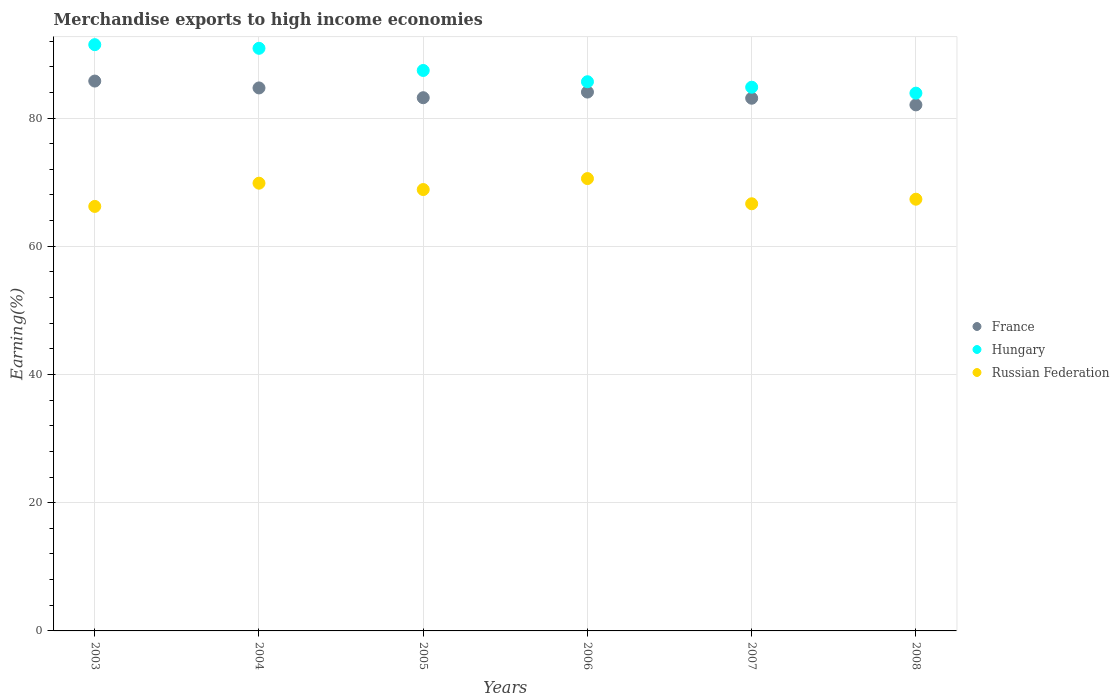How many different coloured dotlines are there?
Offer a terse response. 3. What is the percentage of amount earned from merchandise exports in Hungary in 2003?
Your answer should be very brief. 91.45. Across all years, what is the maximum percentage of amount earned from merchandise exports in Russian Federation?
Your response must be concise. 70.56. Across all years, what is the minimum percentage of amount earned from merchandise exports in Hungary?
Your answer should be very brief. 83.89. In which year was the percentage of amount earned from merchandise exports in Russian Federation maximum?
Your answer should be very brief. 2006. In which year was the percentage of amount earned from merchandise exports in France minimum?
Ensure brevity in your answer.  2008. What is the total percentage of amount earned from merchandise exports in France in the graph?
Offer a terse response. 502.85. What is the difference between the percentage of amount earned from merchandise exports in France in 2004 and that in 2008?
Your answer should be very brief. 2.64. What is the difference between the percentage of amount earned from merchandise exports in Hungary in 2006 and the percentage of amount earned from merchandise exports in France in 2008?
Give a very brief answer. 3.61. What is the average percentage of amount earned from merchandise exports in Russian Federation per year?
Give a very brief answer. 68.24. In the year 2006, what is the difference between the percentage of amount earned from merchandise exports in Russian Federation and percentage of amount earned from merchandise exports in France?
Your response must be concise. -13.49. What is the ratio of the percentage of amount earned from merchandise exports in France in 2003 to that in 2005?
Your answer should be compact. 1.03. What is the difference between the highest and the second highest percentage of amount earned from merchandise exports in France?
Make the answer very short. 1.07. What is the difference between the highest and the lowest percentage of amount earned from merchandise exports in France?
Provide a short and direct response. 3.71. Is the sum of the percentage of amount earned from merchandise exports in Hungary in 2003 and 2005 greater than the maximum percentage of amount earned from merchandise exports in Russian Federation across all years?
Your answer should be very brief. Yes. Does the percentage of amount earned from merchandise exports in Russian Federation monotonically increase over the years?
Provide a short and direct response. No. How many dotlines are there?
Give a very brief answer. 3. What is the difference between two consecutive major ticks on the Y-axis?
Keep it short and to the point. 20. How many legend labels are there?
Ensure brevity in your answer.  3. What is the title of the graph?
Provide a short and direct response. Merchandise exports to high income economies. Does "Eritrea" appear as one of the legend labels in the graph?
Your answer should be compact. No. What is the label or title of the Y-axis?
Provide a succinct answer. Earning(%). What is the Earning(%) of France in 2003?
Offer a very short reply. 85.77. What is the Earning(%) in Hungary in 2003?
Offer a very short reply. 91.45. What is the Earning(%) in Russian Federation in 2003?
Provide a succinct answer. 66.22. What is the Earning(%) of France in 2004?
Ensure brevity in your answer.  84.7. What is the Earning(%) in Hungary in 2004?
Ensure brevity in your answer.  90.88. What is the Earning(%) of Russian Federation in 2004?
Provide a succinct answer. 69.84. What is the Earning(%) in France in 2005?
Make the answer very short. 83.17. What is the Earning(%) in Hungary in 2005?
Your answer should be compact. 87.42. What is the Earning(%) of Russian Federation in 2005?
Your answer should be very brief. 68.85. What is the Earning(%) in France in 2006?
Your answer should be very brief. 84.05. What is the Earning(%) of Hungary in 2006?
Ensure brevity in your answer.  85.67. What is the Earning(%) in Russian Federation in 2006?
Offer a very short reply. 70.56. What is the Earning(%) in France in 2007?
Keep it short and to the point. 83.09. What is the Earning(%) of Hungary in 2007?
Your response must be concise. 84.81. What is the Earning(%) in Russian Federation in 2007?
Your response must be concise. 66.63. What is the Earning(%) of France in 2008?
Your answer should be very brief. 82.06. What is the Earning(%) of Hungary in 2008?
Make the answer very short. 83.89. What is the Earning(%) in Russian Federation in 2008?
Your response must be concise. 67.34. Across all years, what is the maximum Earning(%) in France?
Keep it short and to the point. 85.77. Across all years, what is the maximum Earning(%) of Hungary?
Offer a terse response. 91.45. Across all years, what is the maximum Earning(%) in Russian Federation?
Make the answer very short. 70.56. Across all years, what is the minimum Earning(%) of France?
Make the answer very short. 82.06. Across all years, what is the minimum Earning(%) of Hungary?
Make the answer very short. 83.89. Across all years, what is the minimum Earning(%) in Russian Federation?
Provide a succinct answer. 66.22. What is the total Earning(%) of France in the graph?
Offer a very short reply. 502.85. What is the total Earning(%) in Hungary in the graph?
Your answer should be compact. 524.12. What is the total Earning(%) of Russian Federation in the graph?
Your response must be concise. 409.45. What is the difference between the Earning(%) of France in 2003 and that in 2004?
Ensure brevity in your answer.  1.07. What is the difference between the Earning(%) in Hungary in 2003 and that in 2004?
Provide a short and direct response. 0.57. What is the difference between the Earning(%) in Russian Federation in 2003 and that in 2004?
Provide a short and direct response. -3.62. What is the difference between the Earning(%) of France in 2003 and that in 2005?
Keep it short and to the point. 2.6. What is the difference between the Earning(%) of Hungary in 2003 and that in 2005?
Your response must be concise. 4.03. What is the difference between the Earning(%) in Russian Federation in 2003 and that in 2005?
Your response must be concise. -2.63. What is the difference between the Earning(%) of France in 2003 and that in 2006?
Offer a very short reply. 1.72. What is the difference between the Earning(%) in Hungary in 2003 and that in 2006?
Provide a succinct answer. 5.78. What is the difference between the Earning(%) in Russian Federation in 2003 and that in 2006?
Provide a short and direct response. -4.34. What is the difference between the Earning(%) in France in 2003 and that in 2007?
Offer a very short reply. 2.68. What is the difference between the Earning(%) of Hungary in 2003 and that in 2007?
Provide a short and direct response. 6.64. What is the difference between the Earning(%) of Russian Federation in 2003 and that in 2007?
Your answer should be very brief. -0.41. What is the difference between the Earning(%) in France in 2003 and that in 2008?
Offer a very short reply. 3.71. What is the difference between the Earning(%) in Hungary in 2003 and that in 2008?
Provide a succinct answer. 7.56. What is the difference between the Earning(%) of Russian Federation in 2003 and that in 2008?
Ensure brevity in your answer.  -1.13. What is the difference between the Earning(%) of France in 2004 and that in 2005?
Keep it short and to the point. 1.53. What is the difference between the Earning(%) of Hungary in 2004 and that in 2005?
Make the answer very short. 3.46. What is the difference between the Earning(%) in France in 2004 and that in 2006?
Make the answer very short. 0.65. What is the difference between the Earning(%) of Hungary in 2004 and that in 2006?
Give a very brief answer. 5.21. What is the difference between the Earning(%) of Russian Federation in 2004 and that in 2006?
Provide a succinct answer. -0.72. What is the difference between the Earning(%) in France in 2004 and that in 2007?
Make the answer very short. 1.61. What is the difference between the Earning(%) in Hungary in 2004 and that in 2007?
Offer a terse response. 6.07. What is the difference between the Earning(%) in Russian Federation in 2004 and that in 2007?
Ensure brevity in your answer.  3.21. What is the difference between the Earning(%) in France in 2004 and that in 2008?
Make the answer very short. 2.64. What is the difference between the Earning(%) in Hungary in 2004 and that in 2008?
Your answer should be very brief. 6.99. What is the difference between the Earning(%) of Russian Federation in 2004 and that in 2008?
Keep it short and to the point. 2.5. What is the difference between the Earning(%) of France in 2005 and that in 2006?
Ensure brevity in your answer.  -0.88. What is the difference between the Earning(%) of Hungary in 2005 and that in 2006?
Your answer should be compact. 1.76. What is the difference between the Earning(%) of Russian Federation in 2005 and that in 2006?
Provide a succinct answer. -1.71. What is the difference between the Earning(%) of France in 2005 and that in 2007?
Your answer should be compact. 0.08. What is the difference between the Earning(%) of Hungary in 2005 and that in 2007?
Ensure brevity in your answer.  2.61. What is the difference between the Earning(%) of Russian Federation in 2005 and that in 2007?
Your response must be concise. 2.22. What is the difference between the Earning(%) of France in 2005 and that in 2008?
Give a very brief answer. 1.12. What is the difference between the Earning(%) of Hungary in 2005 and that in 2008?
Your response must be concise. 3.54. What is the difference between the Earning(%) of Russian Federation in 2005 and that in 2008?
Keep it short and to the point. 1.51. What is the difference between the Earning(%) of France in 2006 and that in 2007?
Your answer should be very brief. 0.96. What is the difference between the Earning(%) in Hungary in 2006 and that in 2007?
Your answer should be compact. 0.85. What is the difference between the Earning(%) of Russian Federation in 2006 and that in 2007?
Your response must be concise. 3.93. What is the difference between the Earning(%) in France in 2006 and that in 2008?
Your response must be concise. 2. What is the difference between the Earning(%) of Hungary in 2006 and that in 2008?
Your response must be concise. 1.78. What is the difference between the Earning(%) of Russian Federation in 2006 and that in 2008?
Keep it short and to the point. 3.22. What is the difference between the Earning(%) in France in 2007 and that in 2008?
Offer a very short reply. 1.04. What is the difference between the Earning(%) in Hungary in 2007 and that in 2008?
Keep it short and to the point. 0.93. What is the difference between the Earning(%) of Russian Federation in 2007 and that in 2008?
Make the answer very short. -0.71. What is the difference between the Earning(%) of France in 2003 and the Earning(%) of Hungary in 2004?
Your response must be concise. -5.11. What is the difference between the Earning(%) in France in 2003 and the Earning(%) in Russian Federation in 2004?
Provide a short and direct response. 15.93. What is the difference between the Earning(%) in Hungary in 2003 and the Earning(%) in Russian Federation in 2004?
Ensure brevity in your answer.  21.61. What is the difference between the Earning(%) in France in 2003 and the Earning(%) in Hungary in 2005?
Your answer should be compact. -1.65. What is the difference between the Earning(%) of France in 2003 and the Earning(%) of Russian Federation in 2005?
Give a very brief answer. 16.92. What is the difference between the Earning(%) of Hungary in 2003 and the Earning(%) of Russian Federation in 2005?
Offer a terse response. 22.6. What is the difference between the Earning(%) of France in 2003 and the Earning(%) of Hungary in 2006?
Give a very brief answer. 0.11. What is the difference between the Earning(%) of France in 2003 and the Earning(%) of Russian Federation in 2006?
Your answer should be very brief. 15.21. What is the difference between the Earning(%) of Hungary in 2003 and the Earning(%) of Russian Federation in 2006?
Keep it short and to the point. 20.89. What is the difference between the Earning(%) of France in 2003 and the Earning(%) of Hungary in 2007?
Your answer should be compact. 0.96. What is the difference between the Earning(%) of France in 2003 and the Earning(%) of Russian Federation in 2007?
Offer a very short reply. 19.14. What is the difference between the Earning(%) in Hungary in 2003 and the Earning(%) in Russian Federation in 2007?
Your answer should be compact. 24.82. What is the difference between the Earning(%) of France in 2003 and the Earning(%) of Hungary in 2008?
Ensure brevity in your answer.  1.89. What is the difference between the Earning(%) in France in 2003 and the Earning(%) in Russian Federation in 2008?
Keep it short and to the point. 18.43. What is the difference between the Earning(%) of Hungary in 2003 and the Earning(%) of Russian Federation in 2008?
Your response must be concise. 24.11. What is the difference between the Earning(%) of France in 2004 and the Earning(%) of Hungary in 2005?
Your response must be concise. -2.73. What is the difference between the Earning(%) in France in 2004 and the Earning(%) in Russian Federation in 2005?
Give a very brief answer. 15.85. What is the difference between the Earning(%) in Hungary in 2004 and the Earning(%) in Russian Federation in 2005?
Offer a terse response. 22.03. What is the difference between the Earning(%) of France in 2004 and the Earning(%) of Hungary in 2006?
Ensure brevity in your answer.  -0.97. What is the difference between the Earning(%) of France in 2004 and the Earning(%) of Russian Federation in 2006?
Give a very brief answer. 14.14. What is the difference between the Earning(%) of Hungary in 2004 and the Earning(%) of Russian Federation in 2006?
Keep it short and to the point. 20.32. What is the difference between the Earning(%) of France in 2004 and the Earning(%) of Hungary in 2007?
Provide a succinct answer. -0.11. What is the difference between the Earning(%) of France in 2004 and the Earning(%) of Russian Federation in 2007?
Provide a short and direct response. 18.07. What is the difference between the Earning(%) of Hungary in 2004 and the Earning(%) of Russian Federation in 2007?
Your answer should be very brief. 24.25. What is the difference between the Earning(%) of France in 2004 and the Earning(%) of Hungary in 2008?
Your response must be concise. 0.81. What is the difference between the Earning(%) in France in 2004 and the Earning(%) in Russian Federation in 2008?
Make the answer very short. 17.36. What is the difference between the Earning(%) in Hungary in 2004 and the Earning(%) in Russian Federation in 2008?
Offer a terse response. 23.54. What is the difference between the Earning(%) of France in 2005 and the Earning(%) of Hungary in 2006?
Make the answer very short. -2.49. What is the difference between the Earning(%) in France in 2005 and the Earning(%) in Russian Federation in 2006?
Make the answer very short. 12.61. What is the difference between the Earning(%) in Hungary in 2005 and the Earning(%) in Russian Federation in 2006?
Offer a terse response. 16.86. What is the difference between the Earning(%) in France in 2005 and the Earning(%) in Hungary in 2007?
Offer a terse response. -1.64. What is the difference between the Earning(%) of France in 2005 and the Earning(%) of Russian Federation in 2007?
Provide a short and direct response. 16.54. What is the difference between the Earning(%) of Hungary in 2005 and the Earning(%) of Russian Federation in 2007?
Provide a short and direct response. 20.79. What is the difference between the Earning(%) of France in 2005 and the Earning(%) of Hungary in 2008?
Your answer should be compact. -0.71. What is the difference between the Earning(%) of France in 2005 and the Earning(%) of Russian Federation in 2008?
Give a very brief answer. 15.83. What is the difference between the Earning(%) of Hungary in 2005 and the Earning(%) of Russian Federation in 2008?
Provide a succinct answer. 20.08. What is the difference between the Earning(%) of France in 2006 and the Earning(%) of Hungary in 2007?
Your answer should be compact. -0.76. What is the difference between the Earning(%) in France in 2006 and the Earning(%) in Russian Federation in 2007?
Ensure brevity in your answer.  17.42. What is the difference between the Earning(%) in Hungary in 2006 and the Earning(%) in Russian Federation in 2007?
Give a very brief answer. 19.03. What is the difference between the Earning(%) of France in 2006 and the Earning(%) of Hungary in 2008?
Offer a very short reply. 0.17. What is the difference between the Earning(%) in France in 2006 and the Earning(%) in Russian Federation in 2008?
Your answer should be compact. 16.71. What is the difference between the Earning(%) of Hungary in 2006 and the Earning(%) of Russian Federation in 2008?
Make the answer very short. 18.32. What is the difference between the Earning(%) of France in 2007 and the Earning(%) of Hungary in 2008?
Ensure brevity in your answer.  -0.79. What is the difference between the Earning(%) in France in 2007 and the Earning(%) in Russian Federation in 2008?
Offer a terse response. 15.75. What is the difference between the Earning(%) of Hungary in 2007 and the Earning(%) of Russian Federation in 2008?
Offer a very short reply. 17.47. What is the average Earning(%) in France per year?
Offer a very short reply. 83.81. What is the average Earning(%) of Hungary per year?
Offer a very short reply. 87.35. What is the average Earning(%) of Russian Federation per year?
Offer a very short reply. 68.24. In the year 2003, what is the difference between the Earning(%) of France and Earning(%) of Hungary?
Provide a short and direct response. -5.68. In the year 2003, what is the difference between the Earning(%) of France and Earning(%) of Russian Federation?
Keep it short and to the point. 19.55. In the year 2003, what is the difference between the Earning(%) in Hungary and Earning(%) in Russian Federation?
Provide a succinct answer. 25.23. In the year 2004, what is the difference between the Earning(%) in France and Earning(%) in Hungary?
Offer a very short reply. -6.18. In the year 2004, what is the difference between the Earning(%) of France and Earning(%) of Russian Federation?
Your answer should be very brief. 14.86. In the year 2004, what is the difference between the Earning(%) of Hungary and Earning(%) of Russian Federation?
Offer a very short reply. 21.04. In the year 2005, what is the difference between the Earning(%) in France and Earning(%) in Hungary?
Your answer should be compact. -4.25. In the year 2005, what is the difference between the Earning(%) in France and Earning(%) in Russian Federation?
Make the answer very short. 14.32. In the year 2005, what is the difference between the Earning(%) of Hungary and Earning(%) of Russian Federation?
Give a very brief answer. 18.57. In the year 2006, what is the difference between the Earning(%) in France and Earning(%) in Hungary?
Your answer should be compact. -1.61. In the year 2006, what is the difference between the Earning(%) of France and Earning(%) of Russian Federation?
Ensure brevity in your answer.  13.49. In the year 2006, what is the difference between the Earning(%) in Hungary and Earning(%) in Russian Federation?
Offer a very short reply. 15.1. In the year 2007, what is the difference between the Earning(%) of France and Earning(%) of Hungary?
Ensure brevity in your answer.  -1.72. In the year 2007, what is the difference between the Earning(%) of France and Earning(%) of Russian Federation?
Offer a very short reply. 16.46. In the year 2007, what is the difference between the Earning(%) in Hungary and Earning(%) in Russian Federation?
Provide a succinct answer. 18.18. In the year 2008, what is the difference between the Earning(%) of France and Earning(%) of Hungary?
Keep it short and to the point. -1.83. In the year 2008, what is the difference between the Earning(%) in France and Earning(%) in Russian Federation?
Your answer should be compact. 14.71. In the year 2008, what is the difference between the Earning(%) in Hungary and Earning(%) in Russian Federation?
Provide a succinct answer. 16.54. What is the ratio of the Earning(%) of France in 2003 to that in 2004?
Keep it short and to the point. 1.01. What is the ratio of the Earning(%) of Hungary in 2003 to that in 2004?
Provide a short and direct response. 1.01. What is the ratio of the Earning(%) in Russian Federation in 2003 to that in 2004?
Your response must be concise. 0.95. What is the ratio of the Earning(%) in France in 2003 to that in 2005?
Provide a succinct answer. 1.03. What is the ratio of the Earning(%) in Hungary in 2003 to that in 2005?
Your answer should be very brief. 1.05. What is the ratio of the Earning(%) of Russian Federation in 2003 to that in 2005?
Provide a succinct answer. 0.96. What is the ratio of the Earning(%) in France in 2003 to that in 2006?
Give a very brief answer. 1.02. What is the ratio of the Earning(%) in Hungary in 2003 to that in 2006?
Provide a short and direct response. 1.07. What is the ratio of the Earning(%) of Russian Federation in 2003 to that in 2006?
Your answer should be very brief. 0.94. What is the ratio of the Earning(%) of France in 2003 to that in 2007?
Offer a terse response. 1.03. What is the ratio of the Earning(%) in Hungary in 2003 to that in 2007?
Give a very brief answer. 1.08. What is the ratio of the Earning(%) in France in 2003 to that in 2008?
Your answer should be very brief. 1.05. What is the ratio of the Earning(%) of Hungary in 2003 to that in 2008?
Give a very brief answer. 1.09. What is the ratio of the Earning(%) of Russian Federation in 2003 to that in 2008?
Your answer should be very brief. 0.98. What is the ratio of the Earning(%) of France in 2004 to that in 2005?
Offer a terse response. 1.02. What is the ratio of the Earning(%) of Hungary in 2004 to that in 2005?
Give a very brief answer. 1.04. What is the ratio of the Earning(%) of Russian Federation in 2004 to that in 2005?
Provide a succinct answer. 1.01. What is the ratio of the Earning(%) of France in 2004 to that in 2006?
Your response must be concise. 1.01. What is the ratio of the Earning(%) in Hungary in 2004 to that in 2006?
Ensure brevity in your answer.  1.06. What is the ratio of the Earning(%) of France in 2004 to that in 2007?
Make the answer very short. 1.02. What is the ratio of the Earning(%) of Hungary in 2004 to that in 2007?
Offer a terse response. 1.07. What is the ratio of the Earning(%) in Russian Federation in 2004 to that in 2007?
Keep it short and to the point. 1.05. What is the ratio of the Earning(%) of France in 2004 to that in 2008?
Ensure brevity in your answer.  1.03. What is the ratio of the Earning(%) in Hungary in 2004 to that in 2008?
Provide a short and direct response. 1.08. What is the ratio of the Earning(%) of Russian Federation in 2004 to that in 2008?
Keep it short and to the point. 1.04. What is the ratio of the Earning(%) of Hungary in 2005 to that in 2006?
Provide a short and direct response. 1.02. What is the ratio of the Earning(%) in Russian Federation in 2005 to that in 2006?
Keep it short and to the point. 0.98. What is the ratio of the Earning(%) in Hungary in 2005 to that in 2007?
Provide a succinct answer. 1.03. What is the ratio of the Earning(%) of Russian Federation in 2005 to that in 2007?
Offer a very short reply. 1.03. What is the ratio of the Earning(%) of France in 2005 to that in 2008?
Make the answer very short. 1.01. What is the ratio of the Earning(%) in Hungary in 2005 to that in 2008?
Offer a terse response. 1.04. What is the ratio of the Earning(%) of Russian Federation in 2005 to that in 2008?
Your answer should be compact. 1.02. What is the ratio of the Earning(%) of France in 2006 to that in 2007?
Offer a very short reply. 1.01. What is the ratio of the Earning(%) of Russian Federation in 2006 to that in 2007?
Offer a terse response. 1.06. What is the ratio of the Earning(%) of France in 2006 to that in 2008?
Keep it short and to the point. 1.02. What is the ratio of the Earning(%) in Hungary in 2006 to that in 2008?
Your answer should be compact. 1.02. What is the ratio of the Earning(%) of Russian Federation in 2006 to that in 2008?
Ensure brevity in your answer.  1.05. What is the ratio of the Earning(%) of France in 2007 to that in 2008?
Ensure brevity in your answer.  1.01. What is the ratio of the Earning(%) in Russian Federation in 2007 to that in 2008?
Offer a terse response. 0.99. What is the difference between the highest and the second highest Earning(%) in France?
Keep it short and to the point. 1.07. What is the difference between the highest and the second highest Earning(%) of Hungary?
Your response must be concise. 0.57. What is the difference between the highest and the second highest Earning(%) in Russian Federation?
Give a very brief answer. 0.72. What is the difference between the highest and the lowest Earning(%) in France?
Keep it short and to the point. 3.71. What is the difference between the highest and the lowest Earning(%) of Hungary?
Provide a succinct answer. 7.56. What is the difference between the highest and the lowest Earning(%) of Russian Federation?
Make the answer very short. 4.34. 